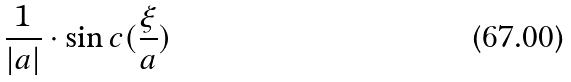<formula> <loc_0><loc_0><loc_500><loc_500>\frac { 1 } { | a | } \cdot \sin c ( \frac { \xi } { a } )</formula> 